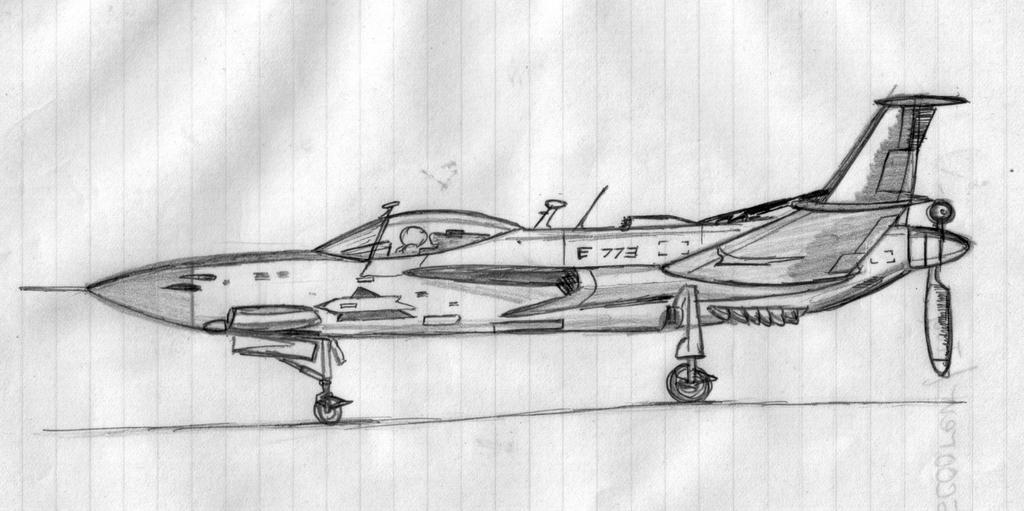What is depicted in the image? There is a drawing of a jet plane in the image. What is the medium of the drawing? The drawing is on a paper. What type of wood is used to create the jet plane in the image? There is no wood present in the image; it is a drawing on paper. How many sacks are visible in the image? There are no sacks present in the image; it features a drawing of a jet plane on paper. 